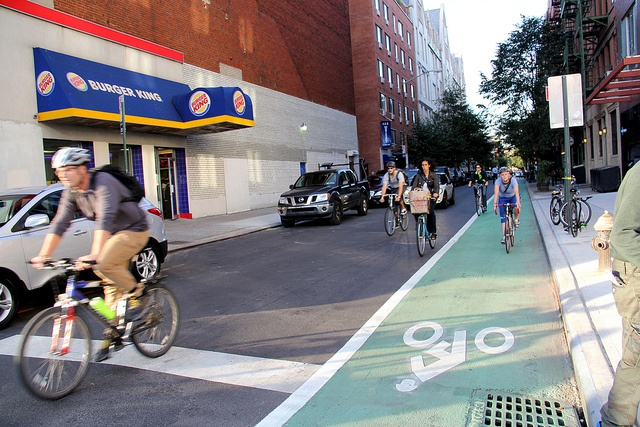Describe the objects in this image and their specific colors. I can see bicycle in brown, gray, lightgray, darkgray, and black tones, people in brown, gray, darkgray, and black tones, car in brown, darkgray, black, lavender, and gray tones, people in brown, darkgray, tan, and white tones, and truck in brown, black, gray, and darkgray tones in this image. 